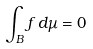Convert formula to latex. <formula><loc_0><loc_0><loc_500><loc_500>\int _ { B } f \, d \mu = 0</formula> 